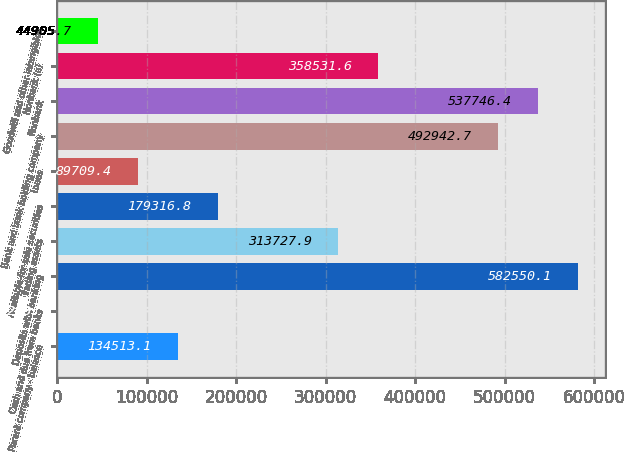Convert chart to OTSL. <chart><loc_0><loc_0><loc_500><loc_500><bar_chart><fcel>Parent company - balance<fcel>Cash and due from banks<fcel>Deposits with banking<fcel>Trading assets<fcel>Available-for-sale securities<fcel>Loans<fcel>Bank and bank holding company<fcel>Nonbank<fcel>Nonbank (a)<fcel>Goodwill and other intangibles<nl><fcel>134513<fcel>102<fcel>582550<fcel>313728<fcel>179317<fcel>89709.4<fcel>492943<fcel>537746<fcel>358532<fcel>44905.7<nl></chart> 